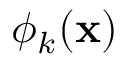Convert formula to latex. <formula><loc_0><loc_0><loc_500><loc_500>\phi _ { k } ( { x } )</formula> 